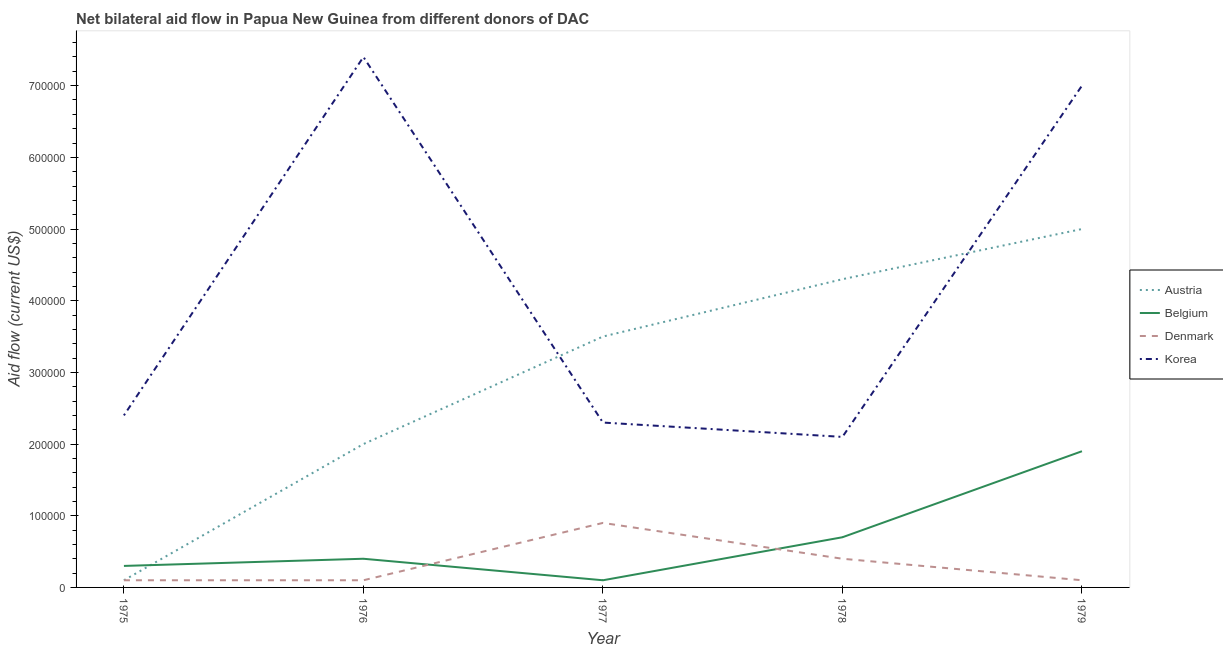How many different coloured lines are there?
Make the answer very short. 4. Does the line corresponding to amount of aid given by korea intersect with the line corresponding to amount of aid given by austria?
Make the answer very short. Yes. What is the amount of aid given by belgium in 1976?
Your response must be concise. 4.00e+04. Across all years, what is the maximum amount of aid given by belgium?
Offer a very short reply. 1.90e+05. Across all years, what is the minimum amount of aid given by korea?
Ensure brevity in your answer.  2.10e+05. In which year was the amount of aid given by belgium maximum?
Your answer should be compact. 1979. In which year was the amount of aid given by korea minimum?
Provide a succinct answer. 1978. What is the total amount of aid given by austria in the graph?
Make the answer very short. 1.49e+06. What is the difference between the amount of aid given by austria in 1976 and that in 1977?
Ensure brevity in your answer.  -1.50e+05. What is the difference between the amount of aid given by korea in 1978 and the amount of aid given by austria in 1976?
Offer a very short reply. 10000. What is the average amount of aid given by denmark per year?
Make the answer very short. 3.20e+04. In the year 1976, what is the difference between the amount of aid given by denmark and amount of aid given by korea?
Provide a succinct answer. -7.30e+05. In how many years, is the amount of aid given by denmark greater than 580000 US$?
Offer a terse response. 0. What is the ratio of the amount of aid given by korea in 1975 to that in 1979?
Ensure brevity in your answer.  0.34. Is the difference between the amount of aid given by korea in 1977 and 1979 greater than the difference between the amount of aid given by austria in 1977 and 1979?
Provide a short and direct response. No. What is the difference between the highest and the second highest amount of aid given by austria?
Your response must be concise. 7.00e+04. What is the difference between the highest and the lowest amount of aid given by belgium?
Provide a short and direct response. 1.80e+05. Is the amount of aid given by belgium strictly greater than the amount of aid given by korea over the years?
Offer a very short reply. No. How many lines are there?
Your answer should be very brief. 4. Does the graph contain any zero values?
Keep it short and to the point. No. Does the graph contain grids?
Your response must be concise. No. How are the legend labels stacked?
Offer a terse response. Vertical. What is the title of the graph?
Your answer should be very brief. Net bilateral aid flow in Papua New Guinea from different donors of DAC. What is the Aid flow (current US$) of Austria in 1975?
Offer a terse response. 10000. What is the Aid flow (current US$) of Belgium in 1975?
Your response must be concise. 3.00e+04. What is the Aid flow (current US$) of Denmark in 1975?
Ensure brevity in your answer.  10000. What is the Aid flow (current US$) in Austria in 1976?
Make the answer very short. 2.00e+05. What is the Aid flow (current US$) of Belgium in 1976?
Your answer should be compact. 4.00e+04. What is the Aid flow (current US$) in Korea in 1976?
Your answer should be compact. 7.40e+05. What is the Aid flow (current US$) in Denmark in 1977?
Provide a succinct answer. 9.00e+04. What is the Aid flow (current US$) of Korea in 1977?
Provide a succinct answer. 2.30e+05. What is the Aid flow (current US$) in Austria in 1978?
Your response must be concise. 4.30e+05. What is the Aid flow (current US$) in Denmark in 1978?
Keep it short and to the point. 4.00e+04. What is the Aid flow (current US$) of Belgium in 1979?
Make the answer very short. 1.90e+05. What is the Aid flow (current US$) in Denmark in 1979?
Your answer should be compact. 10000. What is the Aid flow (current US$) of Korea in 1979?
Ensure brevity in your answer.  7.00e+05. Across all years, what is the maximum Aid flow (current US$) of Korea?
Make the answer very short. 7.40e+05. Across all years, what is the minimum Aid flow (current US$) in Austria?
Your answer should be compact. 10000. What is the total Aid flow (current US$) in Austria in the graph?
Make the answer very short. 1.49e+06. What is the total Aid flow (current US$) of Belgium in the graph?
Make the answer very short. 3.40e+05. What is the total Aid flow (current US$) of Korea in the graph?
Make the answer very short. 2.12e+06. What is the difference between the Aid flow (current US$) of Austria in 1975 and that in 1976?
Your answer should be compact. -1.90e+05. What is the difference between the Aid flow (current US$) in Belgium in 1975 and that in 1976?
Ensure brevity in your answer.  -10000. What is the difference between the Aid flow (current US$) in Korea in 1975 and that in 1976?
Make the answer very short. -5.00e+05. What is the difference between the Aid flow (current US$) in Austria in 1975 and that in 1977?
Keep it short and to the point. -3.40e+05. What is the difference between the Aid flow (current US$) in Korea in 1975 and that in 1977?
Provide a succinct answer. 10000. What is the difference between the Aid flow (current US$) in Austria in 1975 and that in 1978?
Your answer should be compact. -4.20e+05. What is the difference between the Aid flow (current US$) of Belgium in 1975 and that in 1978?
Offer a very short reply. -4.00e+04. What is the difference between the Aid flow (current US$) in Austria in 1975 and that in 1979?
Offer a terse response. -4.90e+05. What is the difference between the Aid flow (current US$) of Korea in 1975 and that in 1979?
Your response must be concise. -4.60e+05. What is the difference between the Aid flow (current US$) in Belgium in 1976 and that in 1977?
Make the answer very short. 3.00e+04. What is the difference between the Aid flow (current US$) in Korea in 1976 and that in 1977?
Give a very brief answer. 5.10e+05. What is the difference between the Aid flow (current US$) in Austria in 1976 and that in 1978?
Ensure brevity in your answer.  -2.30e+05. What is the difference between the Aid flow (current US$) of Korea in 1976 and that in 1978?
Keep it short and to the point. 5.30e+05. What is the difference between the Aid flow (current US$) of Austria in 1976 and that in 1979?
Make the answer very short. -3.00e+05. What is the difference between the Aid flow (current US$) in Denmark in 1976 and that in 1979?
Provide a succinct answer. 0. What is the difference between the Aid flow (current US$) of Korea in 1976 and that in 1979?
Ensure brevity in your answer.  4.00e+04. What is the difference between the Aid flow (current US$) in Belgium in 1977 and that in 1978?
Give a very brief answer. -6.00e+04. What is the difference between the Aid flow (current US$) in Denmark in 1977 and that in 1978?
Your response must be concise. 5.00e+04. What is the difference between the Aid flow (current US$) in Korea in 1977 and that in 1978?
Give a very brief answer. 2.00e+04. What is the difference between the Aid flow (current US$) in Belgium in 1977 and that in 1979?
Offer a terse response. -1.80e+05. What is the difference between the Aid flow (current US$) in Korea in 1977 and that in 1979?
Provide a succinct answer. -4.70e+05. What is the difference between the Aid flow (current US$) of Austria in 1978 and that in 1979?
Provide a succinct answer. -7.00e+04. What is the difference between the Aid flow (current US$) in Korea in 1978 and that in 1979?
Keep it short and to the point. -4.90e+05. What is the difference between the Aid flow (current US$) of Austria in 1975 and the Aid flow (current US$) of Belgium in 1976?
Give a very brief answer. -3.00e+04. What is the difference between the Aid flow (current US$) of Austria in 1975 and the Aid flow (current US$) of Korea in 1976?
Offer a very short reply. -7.30e+05. What is the difference between the Aid flow (current US$) of Belgium in 1975 and the Aid flow (current US$) of Korea in 1976?
Your response must be concise. -7.10e+05. What is the difference between the Aid flow (current US$) in Denmark in 1975 and the Aid flow (current US$) in Korea in 1976?
Your answer should be compact. -7.30e+05. What is the difference between the Aid flow (current US$) of Austria in 1975 and the Aid flow (current US$) of Belgium in 1977?
Your response must be concise. 0. What is the difference between the Aid flow (current US$) in Austria in 1975 and the Aid flow (current US$) in Korea in 1977?
Offer a terse response. -2.20e+05. What is the difference between the Aid flow (current US$) of Belgium in 1975 and the Aid flow (current US$) of Denmark in 1977?
Ensure brevity in your answer.  -6.00e+04. What is the difference between the Aid flow (current US$) in Austria in 1975 and the Aid flow (current US$) in Korea in 1978?
Your answer should be very brief. -2.00e+05. What is the difference between the Aid flow (current US$) of Belgium in 1975 and the Aid flow (current US$) of Denmark in 1978?
Your answer should be very brief. -10000. What is the difference between the Aid flow (current US$) in Belgium in 1975 and the Aid flow (current US$) in Korea in 1978?
Give a very brief answer. -1.80e+05. What is the difference between the Aid flow (current US$) of Denmark in 1975 and the Aid flow (current US$) of Korea in 1978?
Offer a terse response. -2.00e+05. What is the difference between the Aid flow (current US$) of Austria in 1975 and the Aid flow (current US$) of Belgium in 1979?
Ensure brevity in your answer.  -1.80e+05. What is the difference between the Aid flow (current US$) of Austria in 1975 and the Aid flow (current US$) of Denmark in 1979?
Your answer should be very brief. 0. What is the difference between the Aid flow (current US$) in Austria in 1975 and the Aid flow (current US$) in Korea in 1979?
Provide a short and direct response. -6.90e+05. What is the difference between the Aid flow (current US$) in Belgium in 1975 and the Aid flow (current US$) in Denmark in 1979?
Your response must be concise. 2.00e+04. What is the difference between the Aid flow (current US$) in Belgium in 1975 and the Aid flow (current US$) in Korea in 1979?
Keep it short and to the point. -6.70e+05. What is the difference between the Aid flow (current US$) of Denmark in 1975 and the Aid flow (current US$) of Korea in 1979?
Provide a succinct answer. -6.90e+05. What is the difference between the Aid flow (current US$) in Austria in 1976 and the Aid flow (current US$) in Belgium in 1977?
Ensure brevity in your answer.  1.90e+05. What is the difference between the Aid flow (current US$) of Denmark in 1976 and the Aid flow (current US$) of Korea in 1977?
Offer a terse response. -2.20e+05. What is the difference between the Aid flow (current US$) in Austria in 1976 and the Aid flow (current US$) in Belgium in 1978?
Your answer should be very brief. 1.30e+05. What is the difference between the Aid flow (current US$) of Austria in 1976 and the Aid flow (current US$) of Korea in 1978?
Ensure brevity in your answer.  -10000. What is the difference between the Aid flow (current US$) in Belgium in 1976 and the Aid flow (current US$) in Denmark in 1978?
Your answer should be very brief. 0. What is the difference between the Aid flow (current US$) of Belgium in 1976 and the Aid flow (current US$) of Korea in 1978?
Provide a short and direct response. -1.70e+05. What is the difference between the Aid flow (current US$) of Austria in 1976 and the Aid flow (current US$) of Korea in 1979?
Make the answer very short. -5.00e+05. What is the difference between the Aid flow (current US$) in Belgium in 1976 and the Aid flow (current US$) in Korea in 1979?
Your answer should be very brief. -6.60e+05. What is the difference between the Aid flow (current US$) of Denmark in 1976 and the Aid flow (current US$) of Korea in 1979?
Your response must be concise. -6.90e+05. What is the difference between the Aid flow (current US$) in Austria in 1977 and the Aid flow (current US$) in Belgium in 1978?
Your response must be concise. 2.80e+05. What is the difference between the Aid flow (current US$) in Austria in 1977 and the Aid flow (current US$) in Denmark in 1978?
Your response must be concise. 3.10e+05. What is the difference between the Aid flow (current US$) of Austria in 1977 and the Aid flow (current US$) of Korea in 1978?
Your answer should be compact. 1.40e+05. What is the difference between the Aid flow (current US$) in Austria in 1977 and the Aid flow (current US$) in Denmark in 1979?
Keep it short and to the point. 3.40e+05. What is the difference between the Aid flow (current US$) in Austria in 1977 and the Aid flow (current US$) in Korea in 1979?
Make the answer very short. -3.50e+05. What is the difference between the Aid flow (current US$) in Belgium in 1977 and the Aid flow (current US$) in Korea in 1979?
Your answer should be compact. -6.90e+05. What is the difference between the Aid flow (current US$) in Denmark in 1977 and the Aid flow (current US$) in Korea in 1979?
Your answer should be compact. -6.10e+05. What is the difference between the Aid flow (current US$) in Belgium in 1978 and the Aid flow (current US$) in Denmark in 1979?
Offer a very short reply. 6.00e+04. What is the difference between the Aid flow (current US$) of Belgium in 1978 and the Aid flow (current US$) of Korea in 1979?
Offer a very short reply. -6.30e+05. What is the difference between the Aid flow (current US$) of Denmark in 1978 and the Aid flow (current US$) of Korea in 1979?
Offer a terse response. -6.60e+05. What is the average Aid flow (current US$) in Austria per year?
Provide a succinct answer. 2.98e+05. What is the average Aid flow (current US$) in Belgium per year?
Your answer should be compact. 6.80e+04. What is the average Aid flow (current US$) in Denmark per year?
Make the answer very short. 3.20e+04. What is the average Aid flow (current US$) in Korea per year?
Make the answer very short. 4.24e+05. In the year 1975, what is the difference between the Aid flow (current US$) of Belgium and Aid flow (current US$) of Denmark?
Your answer should be very brief. 2.00e+04. In the year 1976, what is the difference between the Aid flow (current US$) in Austria and Aid flow (current US$) in Belgium?
Offer a terse response. 1.60e+05. In the year 1976, what is the difference between the Aid flow (current US$) in Austria and Aid flow (current US$) in Denmark?
Keep it short and to the point. 1.90e+05. In the year 1976, what is the difference between the Aid flow (current US$) in Austria and Aid flow (current US$) in Korea?
Provide a short and direct response. -5.40e+05. In the year 1976, what is the difference between the Aid flow (current US$) of Belgium and Aid flow (current US$) of Korea?
Offer a very short reply. -7.00e+05. In the year 1976, what is the difference between the Aid flow (current US$) of Denmark and Aid flow (current US$) of Korea?
Provide a short and direct response. -7.30e+05. In the year 1977, what is the difference between the Aid flow (current US$) in Austria and Aid flow (current US$) in Denmark?
Make the answer very short. 2.60e+05. In the year 1977, what is the difference between the Aid flow (current US$) of Belgium and Aid flow (current US$) of Denmark?
Your answer should be compact. -8.00e+04. In the year 1978, what is the difference between the Aid flow (current US$) of Austria and Aid flow (current US$) of Belgium?
Keep it short and to the point. 3.60e+05. In the year 1979, what is the difference between the Aid flow (current US$) in Austria and Aid flow (current US$) in Belgium?
Your answer should be compact. 3.10e+05. In the year 1979, what is the difference between the Aid flow (current US$) in Belgium and Aid flow (current US$) in Denmark?
Provide a succinct answer. 1.80e+05. In the year 1979, what is the difference between the Aid flow (current US$) of Belgium and Aid flow (current US$) of Korea?
Ensure brevity in your answer.  -5.10e+05. In the year 1979, what is the difference between the Aid flow (current US$) of Denmark and Aid flow (current US$) of Korea?
Your answer should be compact. -6.90e+05. What is the ratio of the Aid flow (current US$) of Austria in 1975 to that in 1976?
Ensure brevity in your answer.  0.05. What is the ratio of the Aid flow (current US$) of Denmark in 1975 to that in 1976?
Ensure brevity in your answer.  1. What is the ratio of the Aid flow (current US$) of Korea in 1975 to that in 1976?
Ensure brevity in your answer.  0.32. What is the ratio of the Aid flow (current US$) in Austria in 1975 to that in 1977?
Offer a terse response. 0.03. What is the ratio of the Aid flow (current US$) in Belgium in 1975 to that in 1977?
Offer a very short reply. 3. What is the ratio of the Aid flow (current US$) of Korea in 1975 to that in 1977?
Provide a short and direct response. 1.04. What is the ratio of the Aid flow (current US$) in Austria in 1975 to that in 1978?
Provide a short and direct response. 0.02. What is the ratio of the Aid flow (current US$) of Belgium in 1975 to that in 1978?
Provide a succinct answer. 0.43. What is the ratio of the Aid flow (current US$) in Denmark in 1975 to that in 1978?
Offer a terse response. 0.25. What is the ratio of the Aid flow (current US$) of Belgium in 1975 to that in 1979?
Offer a terse response. 0.16. What is the ratio of the Aid flow (current US$) of Denmark in 1975 to that in 1979?
Offer a terse response. 1. What is the ratio of the Aid flow (current US$) of Korea in 1975 to that in 1979?
Your answer should be very brief. 0.34. What is the ratio of the Aid flow (current US$) in Korea in 1976 to that in 1977?
Your response must be concise. 3.22. What is the ratio of the Aid flow (current US$) of Austria in 1976 to that in 1978?
Offer a terse response. 0.47. What is the ratio of the Aid flow (current US$) of Denmark in 1976 to that in 1978?
Give a very brief answer. 0.25. What is the ratio of the Aid flow (current US$) of Korea in 1976 to that in 1978?
Your answer should be compact. 3.52. What is the ratio of the Aid flow (current US$) in Austria in 1976 to that in 1979?
Offer a terse response. 0.4. What is the ratio of the Aid flow (current US$) of Belgium in 1976 to that in 1979?
Offer a very short reply. 0.21. What is the ratio of the Aid flow (current US$) of Korea in 1976 to that in 1979?
Give a very brief answer. 1.06. What is the ratio of the Aid flow (current US$) of Austria in 1977 to that in 1978?
Your answer should be compact. 0.81. What is the ratio of the Aid flow (current US$) in Belgium in 1977 to that in 1978?
Keep it short and to the point. 0.14. What is the ratio of the Aid flow (current US$) in Denmark in 1977 to that in 1978?
Offer a very short reply. 2.25. What is the ratio of the Aid flow (current US$) of Korea in 1977 to that in 1978?
Ensure brevity in your answer.  1.1. What is the ratio of the Aid flow (current US$) in Austria in 1977 to that in 1979?
Offer a very short reply. 0.7. What is the ratio of the Aid flow (current US$) in Belgium in 1977 to that in 1979?
Your response must be concise. 0.05. What is the ratio of the Aid flow (current US$) in Denmark in 1977 to that in 1979?
Your response must be concise. 9. What is the ratio of the Aid flow (current US$) of Korea in 1977 to that in 1979?
Your answer should be very brief. 0.33. What is the ratio of the Aid flow (current US$) of Austria in 1978 to that in 1979?
Give a very brief answer. 0.86. What is the ratio of the Aid flow (current US$) of Belgium in 1978 to that in 1979?
Make the answer very short. 0.37. What is the ratio of the Aid flow (current US$) of Korea in 1978 to that in 1979?
Provide a succinct answer. 0.3. What is the difference between the highest and the second highest Aid flow (current US$) in Austria?
Your response must be concise. 7.00e+04. What is the difference between the highest and the second highest Aid flow (current US$) of Belgium?
Give a very brief answer. 1.20e+05. What is the difference between the highest and the second highest Aid flow (current US$) of Denmark?
Your answer should be very brief. 5.00e+04. What is the difference between the highest and the lowest Aid flow (current US$) of Belgium?
Make the answer very short. 1.80e+05. What is the difference between the highest and the lowest Aid flow (current US$) in Denmark?
Offer a terse response. 8.00e+04. What is the difference between the highest and the lowest Aid flow (current US$) in Korea?
Offer a very short reply. 5.30e+05. 